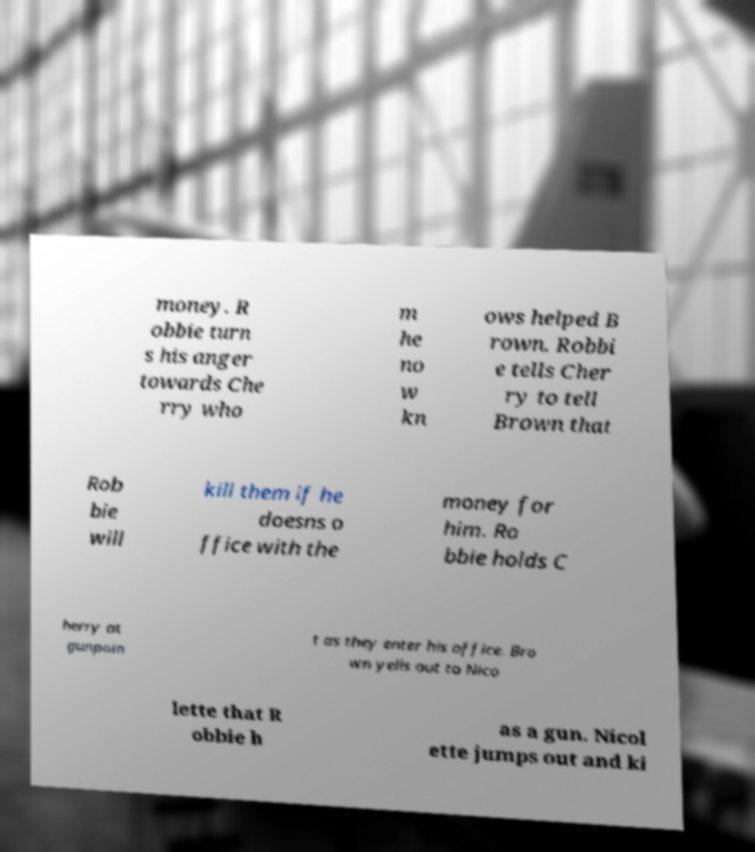Can you accurately transcribe the text from the provided image for me? money. R obbie turn s his anger towards Che rry who m he no w kn ows helped B rown. Robbi e tells Cher ry to tell Brown that Rob bie will kill them if he doesns o ffice with the money for him. Ro bbie holds C herry at gunpoin t as they enter his office. Bro wn yells out to Nico lette that R obbie h as a gun. Nicol ette jumps out and ki 